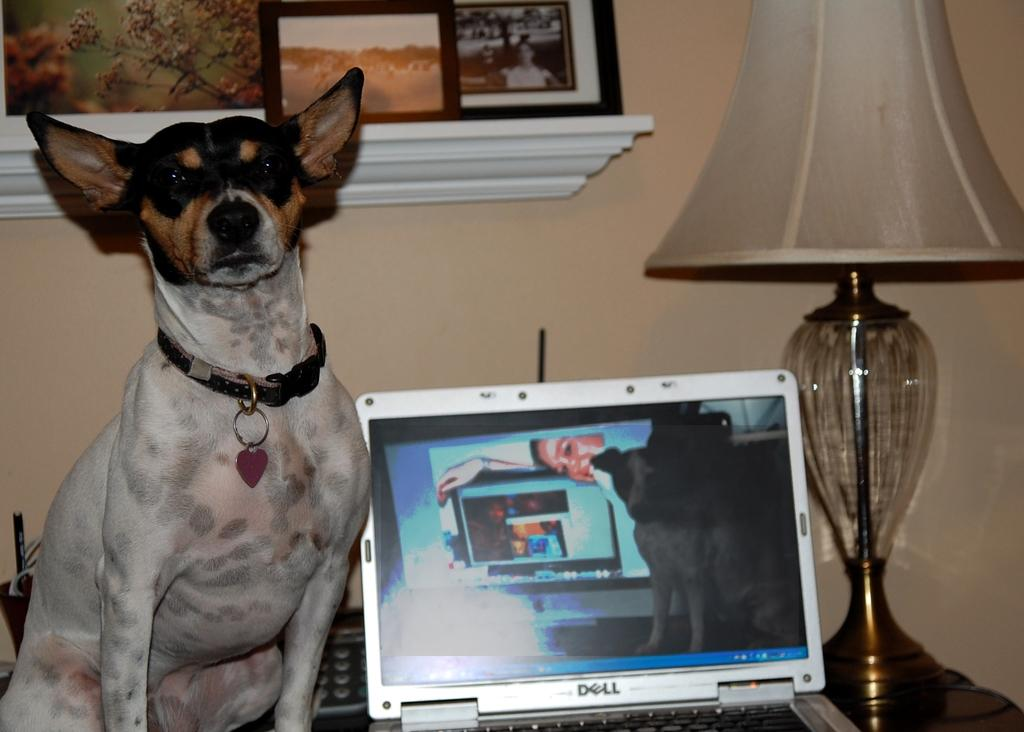What type of animal is in the image? There is a dog in the image. Where is the dog located in the image? The dog is on the left side of the image. What is the dog wearing? The dog is wearing a neck belt. What can be seen on the table in the image? There is a laptop, a lamp, and other objects on the table in the image. What is hanging on the wall in the image? There is a photo frame on a wall in the image. What type of horn can be seen on the dog in the image? There is no horn present on the dog in the image; it is wearing a neck belt. What creature is sleeping on the table in the image? There are no creatures sleeping on the table in the image; only objects like a laptop and a lamp are present. 